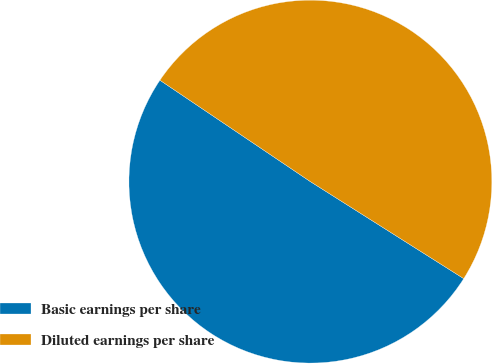Convert chart to OTSL. <chart><loc_0><loc_0><loc_500><loc_500><pie_chart><fcel>Basic earnings per share<fcel>Diluted earnings per share<nl><fcel>50.46%<fcel>49.54%<nl></chart> 